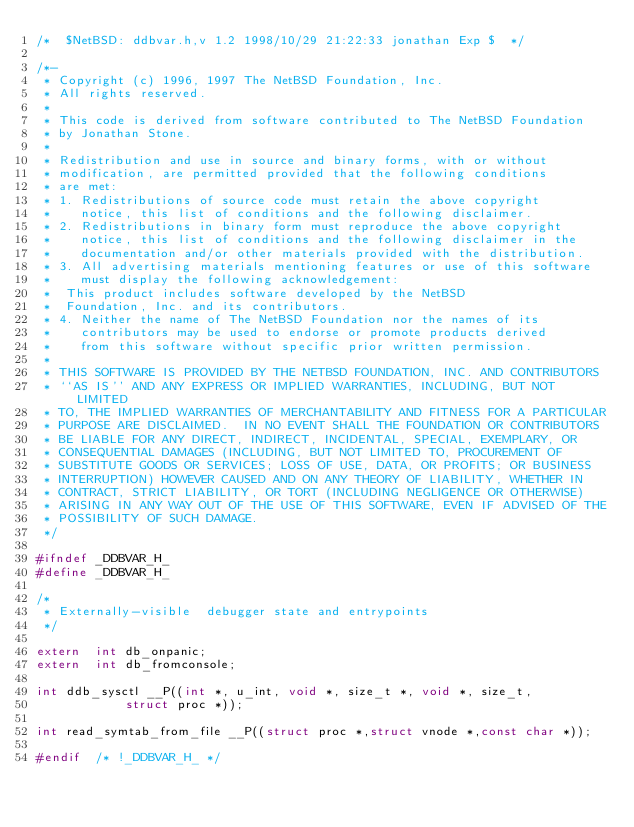Convert code to text. <code><loc_0><loc_0><loc_500><loc_500><_C_>/*	$NetBSD: ddbvar.h,v 1.2 1998/10/29 21:22:33 jonathan Exp $	*/

/*-
 * Copyright (c) 1996, 1997 The NetBSD Foundation, Inc.
 * All rights reserved.
 *
 * This code is derived from software contributed to The NetBSD Foundation
 * by Jonathan Stone.
 *
 * Redistribution and use in source and binary forms, with or without
 * modification, are permitted provided that the following conditions
 * are met:
 * 1. Redistributions of source code must retain the above copyright
 *    notice, this list of conditions and the following disclaimer.
 * 2. Redistributions in binary form must reproduce the above copyright
 *    notice, this list of conditions and the following disclaimer in the
 *    documentation and/or other materials provided with the distribution.
 * 3. All advertising materials mentioning features or use of this software
 *    must display the following acknowledgement:
 *	This product includes software developed by the NetBSD
 *	Foundation, Inc. and its contributors.
 * 4. Neither the name of The NetBSD Foundation nor the names of its
 *    contributors may be used to endorse or promote products derived
 *    from this software without specific prior written permission.
 *
 * THIS SOFTWARE IS PROVIDED BY THE NETBSD FOUNDATION, INC. AND CONTRIBUTORS
 * ``AS IS'' AND ANY EXPRESS OR IMPLIED WARRANTIES, INCLUDING, BUT NOT LIMITED
 * TO, THE IMPLIED WARRANTIES OF MERCHANTABILITY AND FITNESS FOR A PARTICULAR
 * PURPOSE ARE DISCLAIMED.  IN NO EVENT SHALL THE FOUNDATION OR CONTRIBUTORS
 * BE LIABLE FOR ANY DIRECT, INDIRECT, INCIDENTAL, SPECIAL, EXEMPLARY, OR
 * CONSEQUENTIAL DAMAGES (INCLUDING, BUT NOT LIMITED TO, PROCUREMENT OF
 * SUBSTITUTE GOODS OR SERVICES; LOSS OF USE, DATA, OR PROFITS; OR BUSINESS
 * INTERRUPTION) HOWEVER CAUSED AND ON ANY THEORY OF LIABILITY, WHETHER IN
 * CONTRACT, STRICT LIABILITY, OR TORT (INCLUDING NEGLIGENCE OR OTHERWISE)
 * ARISING IN ANY WAY OUT OF THE USE OF THIS SOFTWARE, EVEN IF ADVISED OF THE
 * POSSIBILITY OF SUCH DAMAGE.
 */

#ifndef _DDBVAR_H_
#define _DDBVAR_H_

/*
 * Externally-visible  debugger state and entrypoints
 */

extern	int db_onpanic;
extern	int db_fromconsole;

int ddb_sysctl __P((int *, u_int, void *, size_t *, void *, size_t,
		    struct proc *));

int	read_symtab_from_file __P((struct proc *,struct vnode *,const char *));

#endif	/* !_DDBVAR_H_ */
</code> 